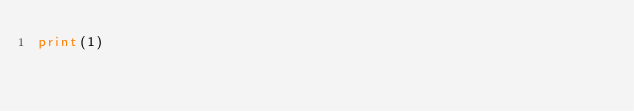Convert code to text. <code><loc_0><loc_0><loc_500><loc_500><_Python_>print(1)</code> 